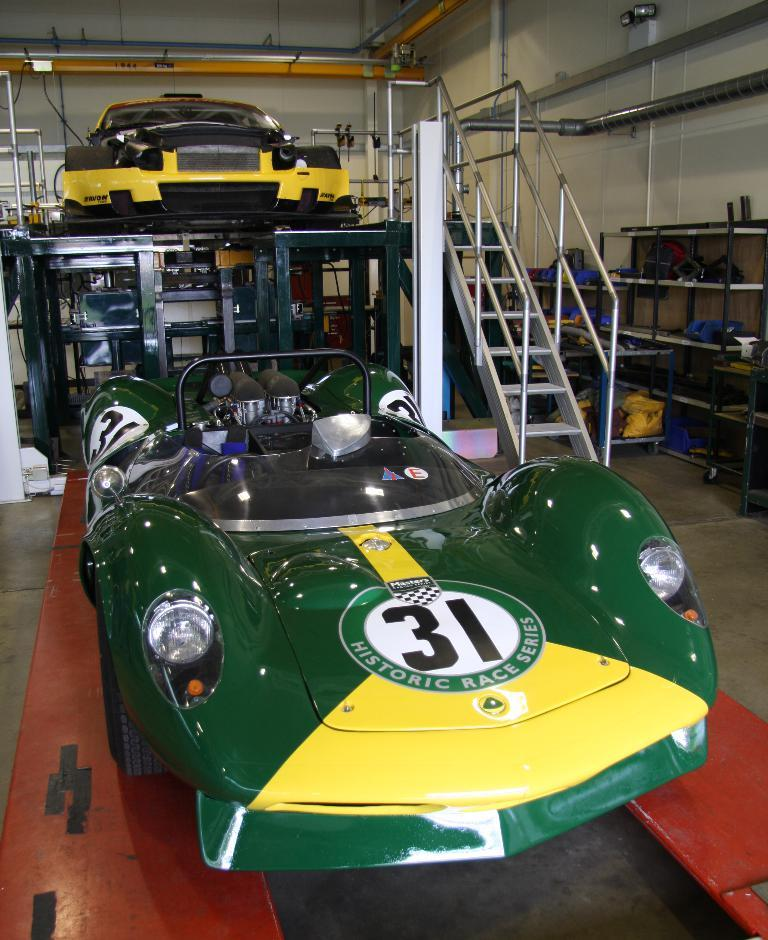What is located in the center of the image? There are vehicles in the center of the image. What can be seen on the right side of the image? There are stairs on the right side of the image. What type of structures are visible in the image? There are stands visible in the image. What is visible in the background of the image? There is a wall and pipes in the background of the image. What flavor of cakes can be seen on the vehicles in the image? There are no cakes present in the image; it features vehicles, stairs, stands, a wall, and pipes. How many cars are parked on the stairs in the image? There are no cars present on the stairs in the image; it features vehicles, stairs, stands, a wall, and pipes. 